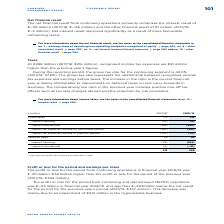According to Metro Ag's financial document, What was the amount of recognised income tax expenses in FY2019? According to the financial document, €298 million. The relevant text states: "Taxes At €298 million (2017/18: €216 million), recognised income tax expenses are €81 million..." Also, What does the group tax rate represent? Based on the financial document, the answer is the relationship between recognised income tax expenses and earnings before taxes. Also, What were the components under Deferred taxes in the table? The document shows two values: thereof Germany and thereof international. From the document: "thereof international (159) (206) thereof Germany (14) (9)..." Additionally, In which year was the total amount of taxes larger? Based on the financial document, the answer is 2018/2019. Also, can you calculate: What was the change in total taxes in  2018/2019 from 2017/2018? Based on the calculation: 298-216, the result is 82 (in millions). This is based on the information: "216 298 216 298..." The key data points involved are: 216, 298. Also, can you calculate: What was the percentage change in total taxes in  2018/2019 from 2017/2018? To answer this question, I need to perform calculations using the financial data. The calculation is: (298-216)/216, which equals 37.96 (percentage). This is based on the information: "216 298 216 298..." The key data points involved are: 216, 298. 